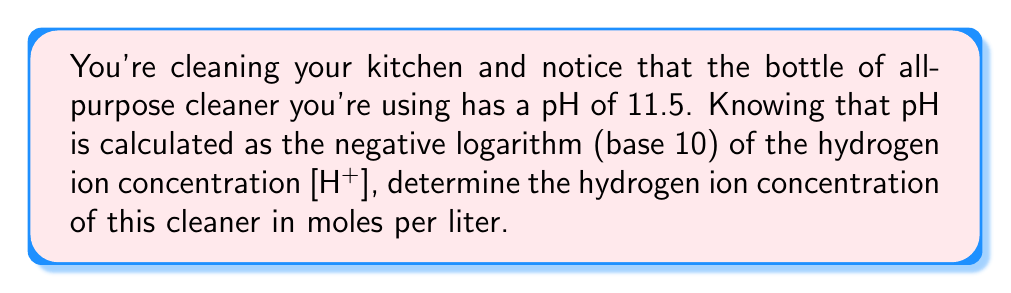Teach me how to tackle this problem. Let's approach this step-by-step:

1) The formula for pH is:
   $$ pH = -\log_{10}[H^+] $$

2) We're given that the pH is 11.5, so we can substitute this:
   $$ 11.5 = -\log_{10}[H^+] $$

3) To solve for [H+], we need to "undo" the negative logarithm. We can do this by raising both sides as a power of 10:
   $$ 10^{-11.5} = 10^{-(-\log_{10}[H^+])} $$

4) The right side simplifies to just [H+]:
   $$ 10^{-11.5} = [H^+] $$

5) Now we just need to calculate 10^(-11.5):
   $$ [H^+] = 10^{-11.5} = 3.16 \times 10^{-12} \text{ mol/L} $$

This very low concentration of hydrogen ions is consistent with the high pH, indicating a basic solution, which is typical for many household cleaners.
Answer: $3.16 \times 10^{-12} \text{ mol/L}$ 